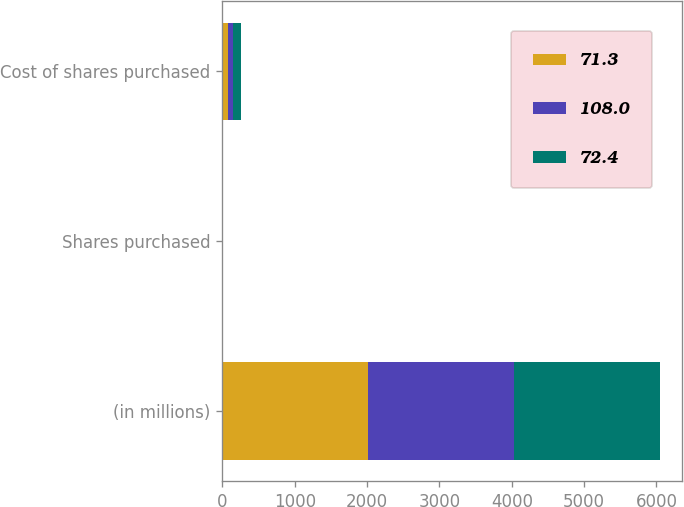Convert chart to OTSL. <chart><loc_0><loc_0><loc_500><loc_500><stacked_bar_chart><ecel><fcel>(in millions)<fcel>Shares purchased<fcel>Cost of shares purchased<nl><fcel>71.3<fcel>2018<fcel>1.1<fcel>72.4<nl><fcel>108<fcel>2017<fcel>1.1<fcel>71.3<nl><fcel>72.4<fcel>2016<fcel>1.8<fcel>108<nl></chart> 